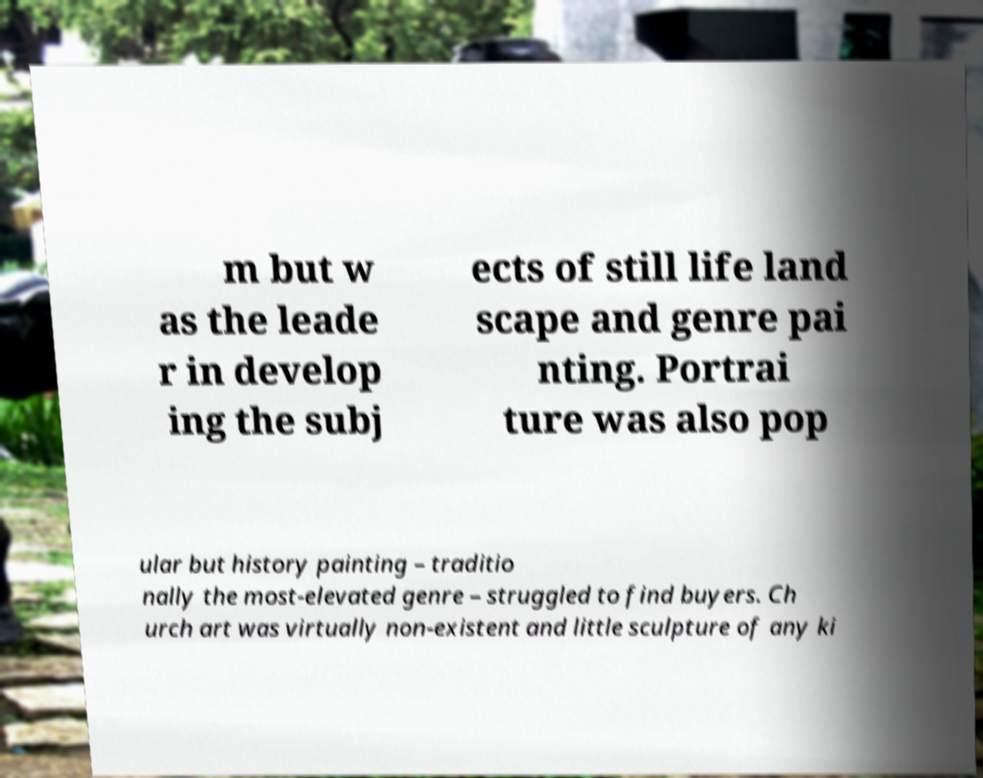Can you accurately transcribe the text from the provided image for me? m but w as the leade r in develop ing the subj ects of still life land scape and genre pai nting. Portrai ture was also pop ular but history painting – traditio nally the most-elevated genre – struggled to find buyers. Ch urch art was virtually non-existent and little sculpture of any ki 